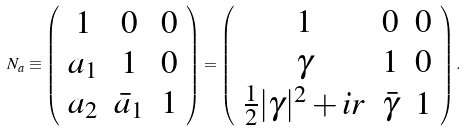<formula> <loc_0><loc_0><loc_500><loc_500>N _ { a } \equiv \left ( \begin{array} { c c c } 1 & 0 & 0 \\ a _ { 1 } & 1 & 0 \\ a _ { 2 } & \bar { a } _ { 1 } & 1 \end{array} \right ) = \left ( \begin{array} { c c c } 1 & 0 & 0 \\ \gamma & 1 & 0 \\ \frac { 1 } { 2 } | \gamma | ^ { 2 } + i r & \bar { \gamma } & 1 \end{array} \right ) .</formula> 